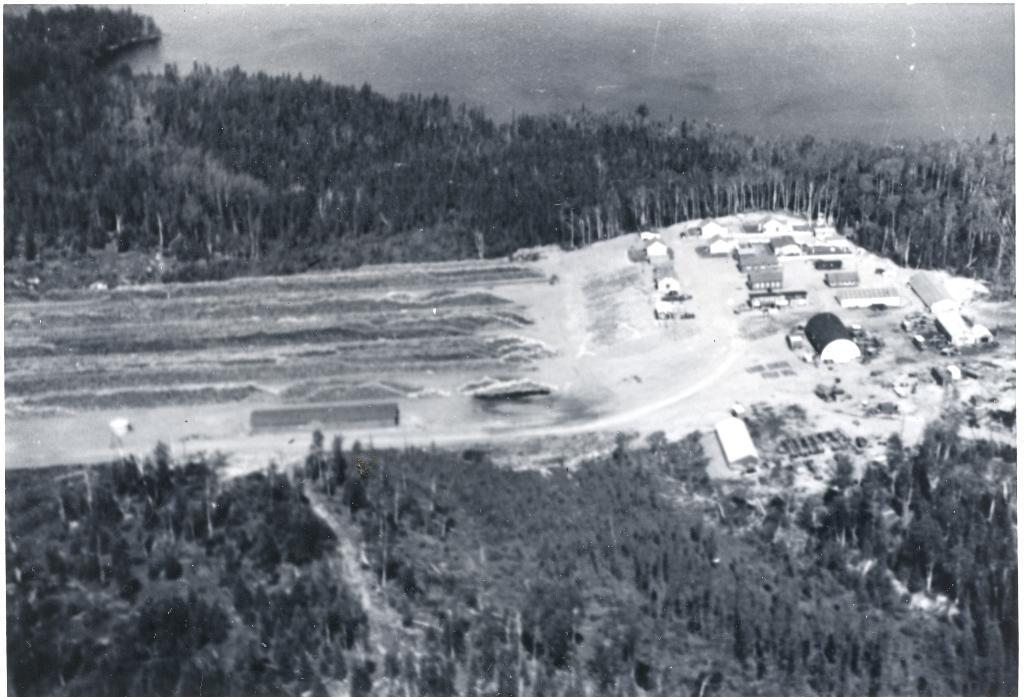Could you give a brief overview of what you see in this image? This is a black and white image. There are trees in the middle and bottom. There are some houses on the right side. There is sky at the top. 